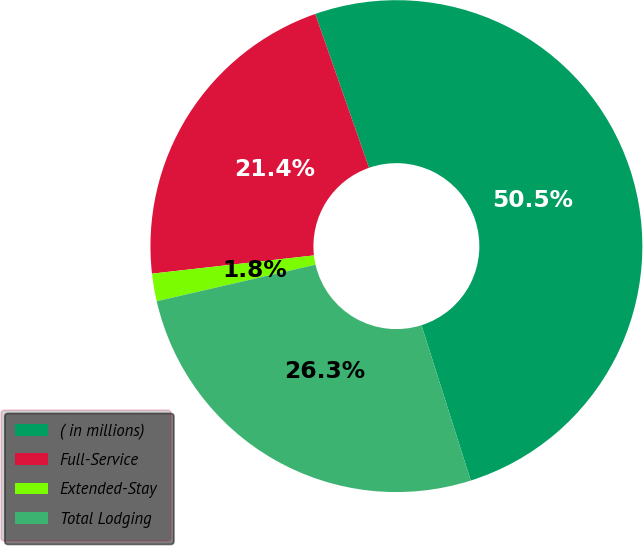<chart> <loc_0><loc_0><loc_500><loc_500><pie_chart><fcel>( in millions)<fcel>Full-Service<fcel>Extended-Stay<fcel>Total Lodging<nl><fcel>50.46%<fcel>21.43%<fcel>1.81%<fcel>26.29%<nl></chart> 